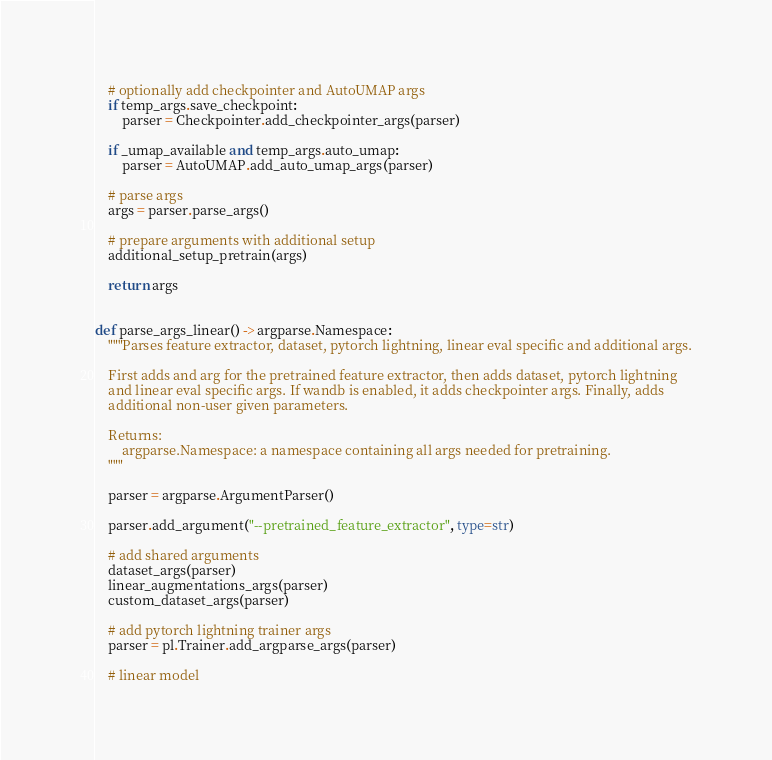Convert code to text. <code><loc_0><loc_0><loc_500><loc_500><_Python_>
    # optionally add checkpointer and AutoUMAP args
    if temp_args.save_checkpoint:
        parser = Checkpointer.add_checkpointer_args(parser)

    if _umap_available and temp_args.auto_umap:
        parser = AutoUMAP.add_auto_umap_args(parser)

    # parse args
    args = parser.parse_args()

    # prepare arguments with additional setup
    additional_setup_pretrain(args)

    return args


def parse_args_linear() -> argparse.Namespace:
    """Parses feature extractor, dataset, pytorch lightning, linear eval specific and additional args.

    First adds and arg for the pretrained feature extractor, then adds dataset, pytorch lightning
    and linear eval specific args. If wandb is enabled, it adds checkpointer args. Finally, adds
    additional non-user given parameters.

    Returns:
        argparse.Namespace: a namespace containing all args needed for pretraining.
    """

    parser = argparse.ArgumentParser()

    parser.add_argument("--pretrained_feature_extractor", type=str)

    # add shared arguments
    dataset_args(parser)
    linear_augmentations_args(parser)
    custom_dataset_args(parser)

    # add pytorch lightning trainer args
    parser = pl.Trainer.add_argparse_args(parser)

    # linear model</code> 